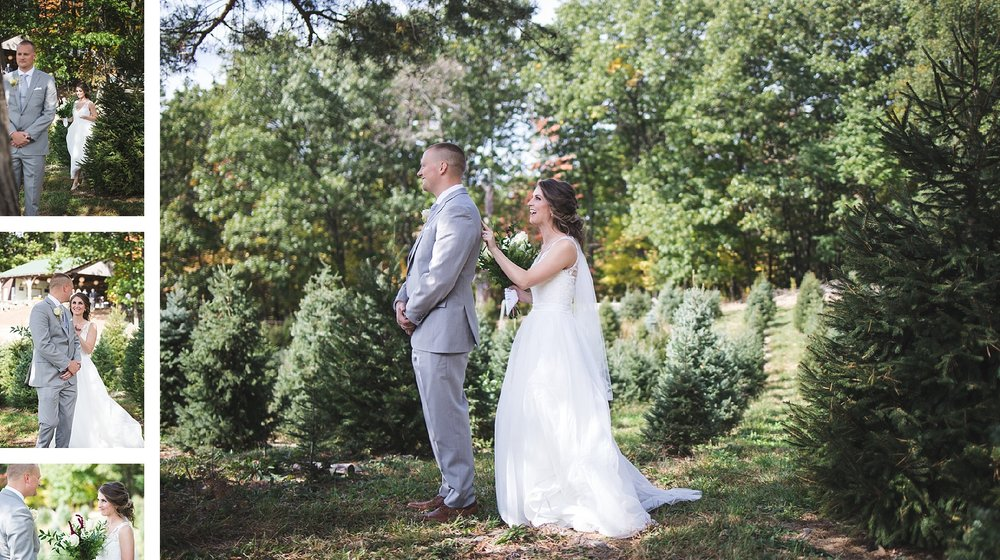Imagine you are a guest at this wedding, what other details can you observe that contribute to the event's atmosphere? As a guest observing this scene, you would notice several details that contribute to the event's warm and inviting atmosphere. The natural light filtering through the trees creates a soft and magical ambience, emphasizing the couple's glowing expressions. The sound of leaves rustling gently in the breeze might accompany the murmur of other guests, enhancing the sense of a tranquil, secluded retreat. The careful arrangement of the outdoor space, without excess decorations, allows the natural beauty to stand out, suggesting that the couple values simplicity and authenticity. In this intimate setting, one can almost hear laughter and soft music, filling the air with celebration and joy. 